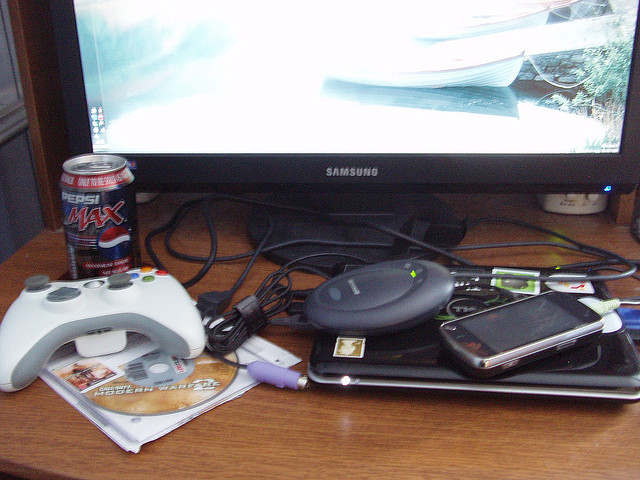Please transcribe the text in this image. SAMSUNG MODERN WARFARE 